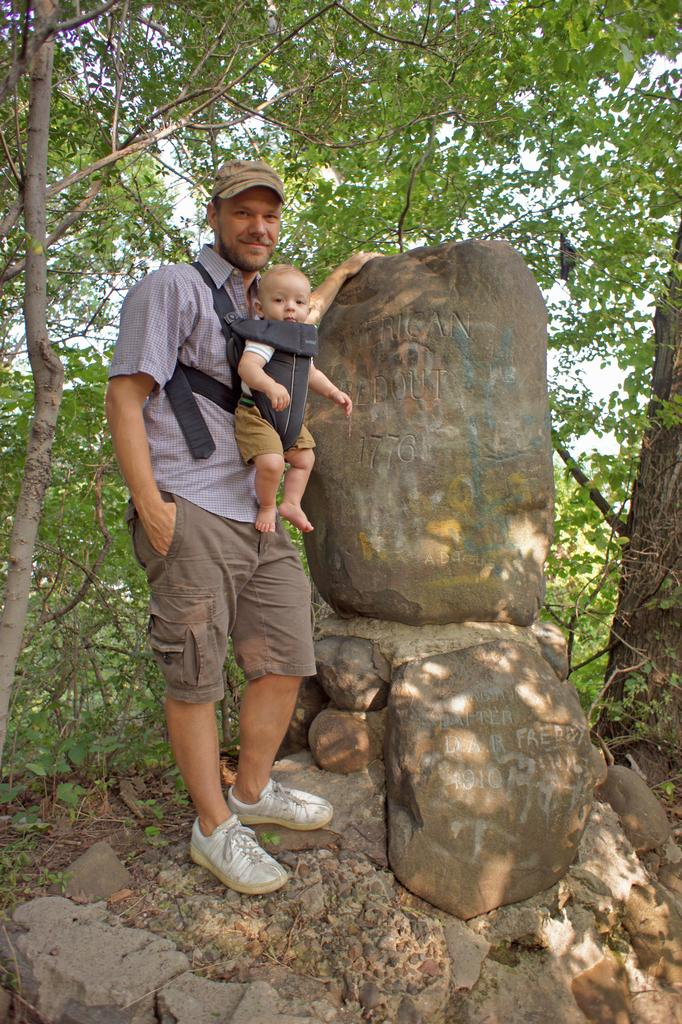What is the man on the left side of the image doing? The man is standing on the left side of the image and holding a baby. What type of clothing is the man wearing? The man is wearing a shirt and shorts. What can be seen in the background of the image? There are trees visible in the image. What type of bulb is the man using to push the baby in the image? There is no bulb present in the image, and the man is not pushing the baby. What color is the button on the baby's clothing in the image? There is no button visible on the baby's clothing in the image. 